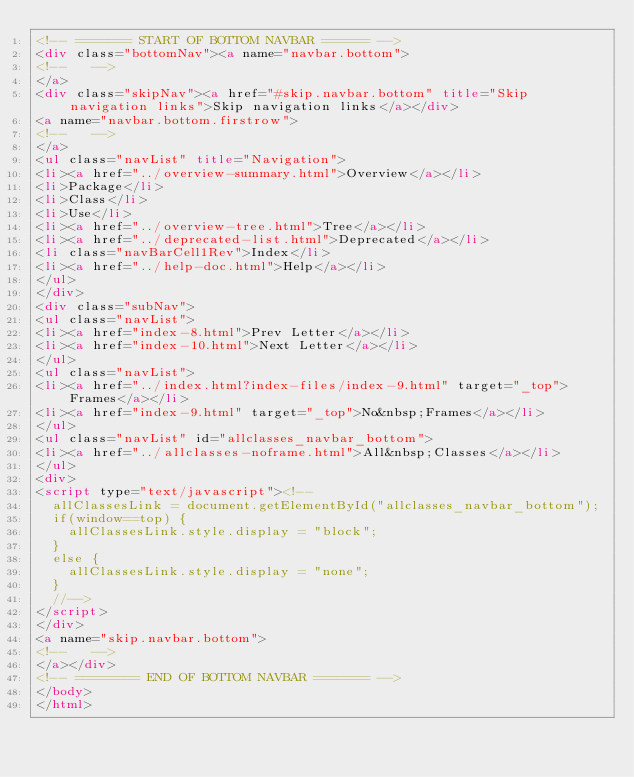<code> <loc_0><loc_0><loc_500><loc_500><_HTML_><!-- ======= START OF BOTTOM NAVBAR ====== -->
<div class="bottomNav"><a name="navbar.bottom">
<!--   -->
</a>
<div class="skipNav"><a href="#skip.navbar.bottom" title="Skip navigation links">Skip navigation links</a></div>
<a name="navbar.bottom.firstrow">
<!--   -->
</a>
<ul class="navList" title="Navigation">
<li><a href="../overview-summary.html">Overview</a></li>
<li>Package</li>
<li>Class</li>
<li>Use</li>
<li><a href="../overview-tree.html">Tree</a></li>
<li><a href="../deprecated-list.html">Deprecated</a></li>
<li class="navBarCell1Rev">Index</li>
<li><a href="../help-doc.html">Help</a></li>
</ul>
</div>
<div class="subNav">
<ul class="navList">
<li><a href="index-8.html">Prev Letter</a></li>
<li><a href="index-10.html">Next Letter</a></li>
</ul>
<ul class="navList">
<li><a href="../index.html?index-files/index-9.html" target="_top">Frames</a></li>
<li><a href="index-9.html" target="_top">No&nbsp;Frames</a></li>
</ul>
<ul class="navList" id="allclasses_navbar_bottom">
<li><a href="../allclasses-noframe.html">All&nbsp;Classes</a></li>
</ul>
<div>
<script type="text/javascript"><!--
  allClassesLink = document.getElementById("allclasses_navbar_bottom");
  if(window==top) {
    allClassesLink.style.display = "block";
  }
  else {
    allClassesLink.style.display = "none";
  }
  //-->
</script>
</div>
<a name="skip.navbar.bottom">
<!--   -->
</a></div>
<!-- ======== END OF BOTTOM NAVBAR ======= -->
</body>
</html>
</code> 